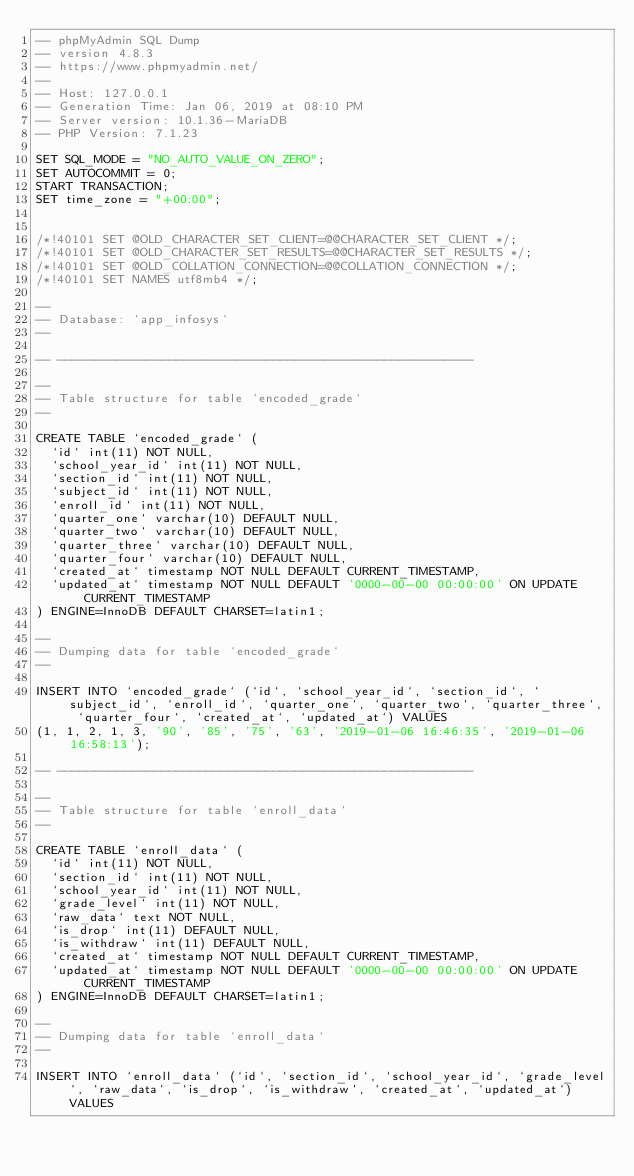Convert code to text. <code><loc_0><loc_0><loc_500><loc_500><_SQL_>-- phpMyAdmin SQL Dump
-- version 4.8.3
-- https://www.phpmyadmin.net/
--
-- Host: 127.0.0.1
-- Generation Time: Jan 06, 2019 at 08:10 PM
-- Server version: 10.1.36-MariaDB
-- PHP Version: 7.1.23

SET SQL_MODE = "NO_AUTO_VALUE_ON_ZERO";
SET AUTOCOMMIT = 0;
START TRANSACTION;
SET time_zone = "+00:00";


/*!40101 SET @OLD_CHARACTER_SET_CLIENT=@@CHARACTER_SET_CLIENT */;
/*!40101 SET @OLD_CHARACTER_SET_RESULTS=@@CHARACTER_SET_RESULTS */;
/*!40101 SET @OLD_COLLATION_CONNECTION=@@COLLATION_CONNECTION */;
/*!40101 SET NAMES utf8mb4 */;

--
-- Database: `app_infosys`
--

-- --------------------------------------------------------

--
-- Table structure for table `encoded_grade`
--

CREATE TABLE `encoded_grade` (
  `id` int(11) NOT NULL,
  `school_year_id` int(11) NOT NULL,
  `section_id` int(11) NOT NULL,
  `subject_id` int(11) NOT NULL,
  `enroll_id` int(11) NOT NULL,
  `quarter_one` varchar(10) DEFAULT NULL,
  `quarter_two` varchar(10) DEFAULT NULL,
  `quarter_three` varchar(10) DEFAULT NULL,
  `quarter_four` varchar(10) DEFAULT NULL,
  `created_at` timestamp NOT NULL DEFAULT CURRENT_TIMESTAMP,
  `updated_at` timestamp NOT NULL DEFAULT '0000-00-00 00:00:00' ON UPDATE CURRENT_TIMESTAMP
) ENGINE=InnoDB DEFAULT CHARSET=latin1;

--
-- Dumping data for table `encoded_grade`
--

INSERT INTO `encoded_grade` (`id`, `school_year_id`, `section_id`, `subject_id`, `enroll_id`, `quarter_one`, `quarter_two`, `quarter_three`, `quarter_four`, `created_at`, `updated_at`) VALUES
(1, 1, 2, 1, 3, '90', '85', '75', '63', '2019-01-06 16:46:35', '2019-01-06 16:58:13');

-- --------------------------------------------------------

--
-- Table structure for table `enroll_data`
--

CREATE TABLE `enroll_data` (
  `id` int(11) NOT NULL,
  `section_id` int(11) NOT NULL,
  `school_year_id` int(11) NOT NULL,
  `grade_level` int(11) NOT NULL,
  `raw_data` text NOT NULL,
  `is_drop` int(11) DEFAULT NULL,
  `is_withdraw` int(11) DEFAULT NULL,
  `created_at` timestamp NOT NULL DEFAULT CURRENT_TIMESTAMP,
  `updated_at` timestamp NOT NULL DEFAULT '0000-00-00 00:00:00' ON UPDATE CURRENT_TIMESTAMP
) ENGINE=InnoDB DEFAULT CHARSET=latin1;

--
-- Dumping data for table `enroll_data`
--

INSERT INTO `enroll_data` (`id`, `section_id`, `school_year_id`, `grade_level`, `raw_data`, `is_drop`, `is_withdraw`, `created_at`, `updated_at`) VALUES</code> 